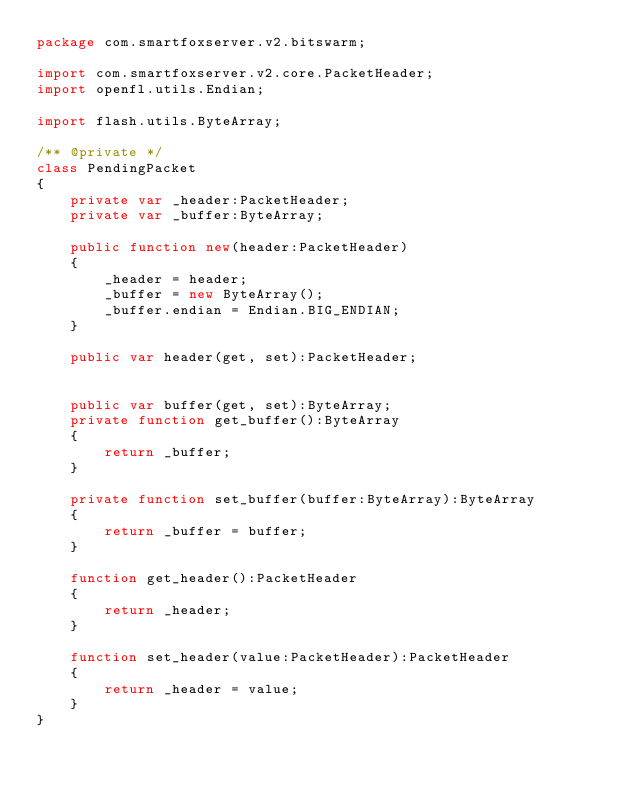<code> <loc_0><loc_0><loc_500><loc_500><_Haxe_>package com.smartfoxserver.v2.bitswarm;

import com.smartfoxserver.v2.core.PacketHeader;
import openfl.utils.Endian;

import flash.utils.ByteArray;

/** @private */
class PendingPacket
{
	private var _header:PacketHeader;
	private var _buffer:ByteArray;
	
	public function new(header:PacketHeader)
	{
		_header = header;
		_buffer = new ByteArray();
		_buffer.endian = Endian.BIG_ENDIAN;
	}
	
	public var header(get, set):PacketHeader;
	
	
	public var buffer(get, set):ByteArray;
 	private function get_buffer():ByteArray
	{
		return _buffer;
	}
	
	private function set_buffer(buffer:ByteArray):ByteArray
	{
		return _buffer = buffer;
	}
	
	function get_header():PacketHeader 
	{
		return _header;
	}
	
	function set_header(value:PacketHeader):PacketHeader 
	{
		return _header = value;
	}
}</code> 